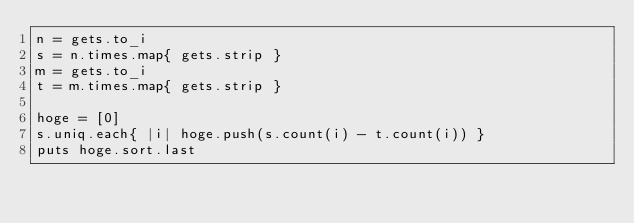Convert code to text. <code><loc_0><loc_0><loc_500><loc_500><_Ruby_>n = gets.to_i
s = n.times.map{ gets.strip }
m = gets.to_i
t = m.times.map{ gets.strip }

hoge = [0]
s.uniq.each{ |i| hoge.push(s.count(i) - t.count(i)) }
puts hoge.sort.last</code> 